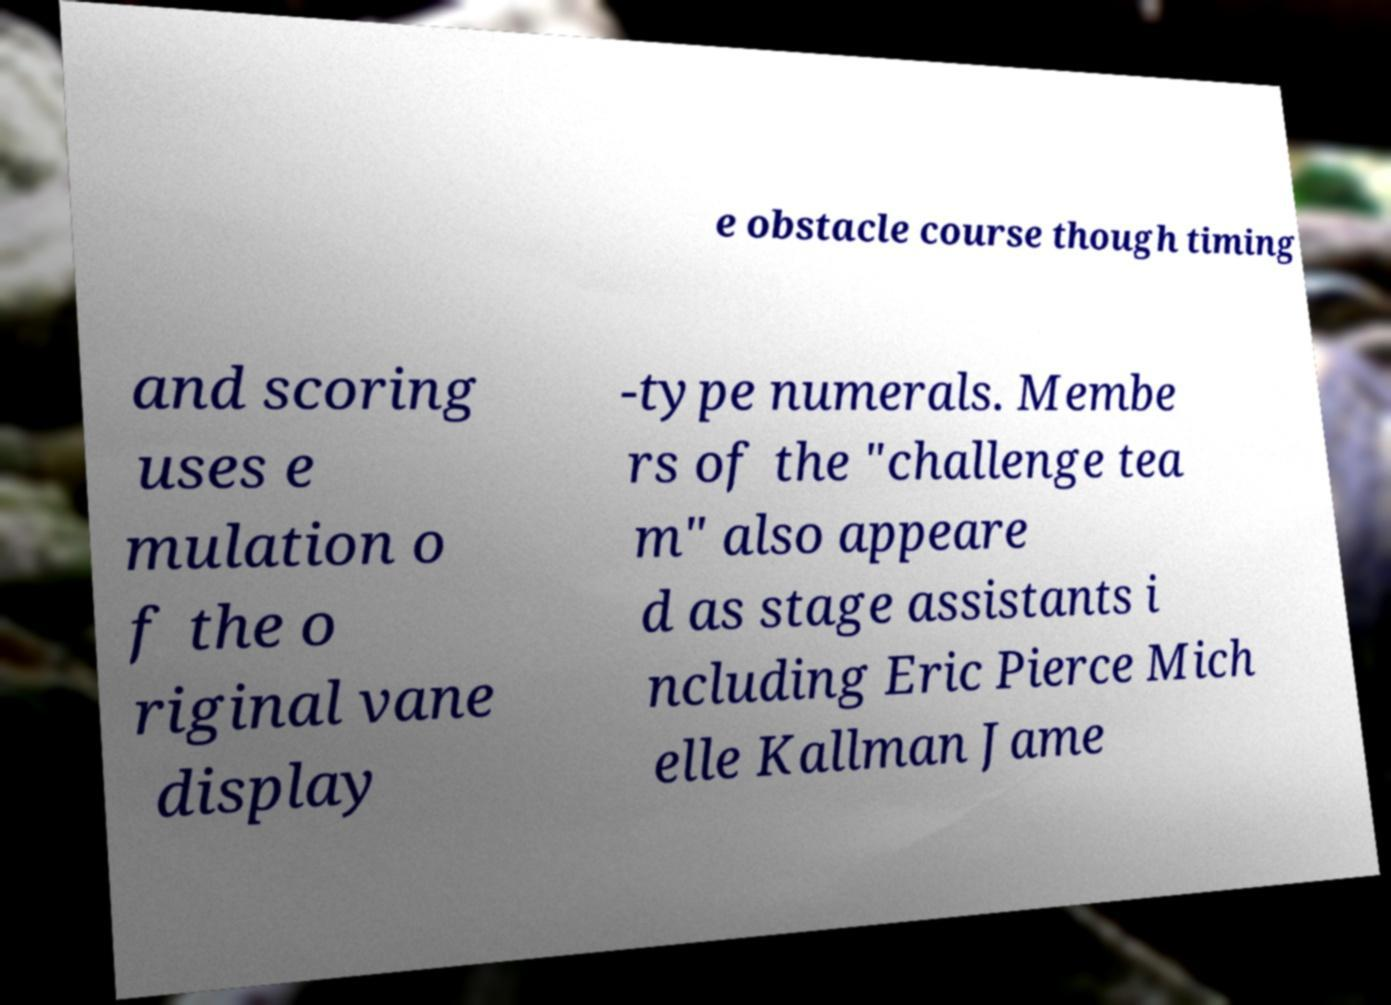Could you assist in decoding the text presented in this image and type it out clearly? e obstacle course though timing and scoring uses e mulation o f the o riginal vane display -type numerals. Membe rs of the "challenge tea m" also appeare d as stage assistants i ncluding Eric Pierce Mich elle Kallman Jame 